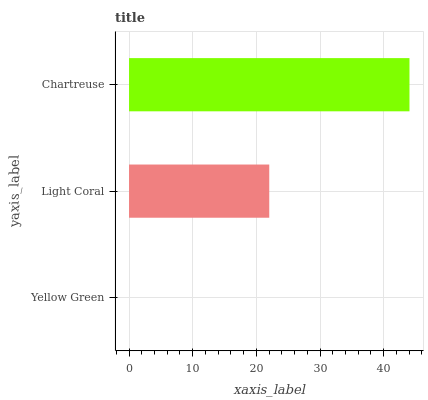Is Yellow Green the minimum?
Answer yes or no. Yes. Is Chartreuse the maximum?
Answer yes or no. Yes. Is Light Coral the minimum?
Answer yes or no. No. Is Light Coral the maximum?
Answer yes or no. No. Is Light Coral greater than Yellow Green?
Answer yes or no. Yes. Is Yellow Green less than Light Coral?
Answer yes or no. Yes. Is Yellow Green greater than Light Coral?
Answer yes or no. No. Is Light Coral less than Yellow Green?
Answer yes or no. No. Is Light Coral the high median?
Answer yes or no. Yes. Is Light Coral the low median?
Answer yes or no. Yes. Is Chartreuse the high median?
Answer yes or no. No. Is Chartreuse the low median?
Answer yes or no. No. 